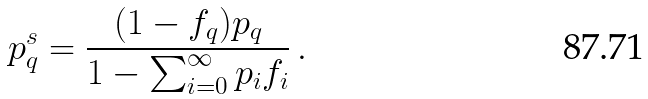Convert formula to latex. <formula><loc_0><loc_0><loc_500><loc_500>p ^ { s } _ { q } = \frac { ( 1 - f _ { q } ) p _ { q } } { 1 - \sum _ { i = 0 } ^ { \infty } p _ { i } f _ { i } } \, .</formula> 